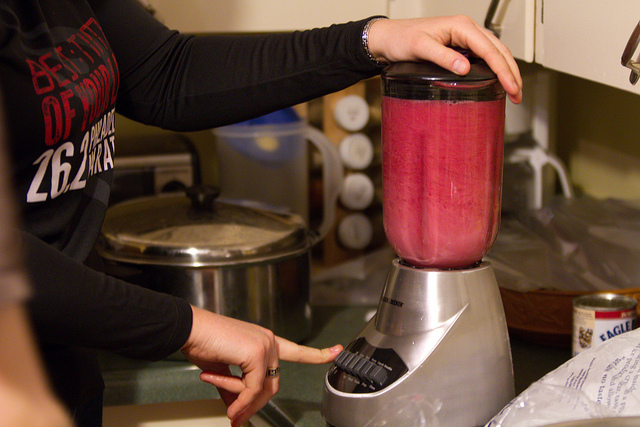Please identify all text content in this image. OF 26.2 